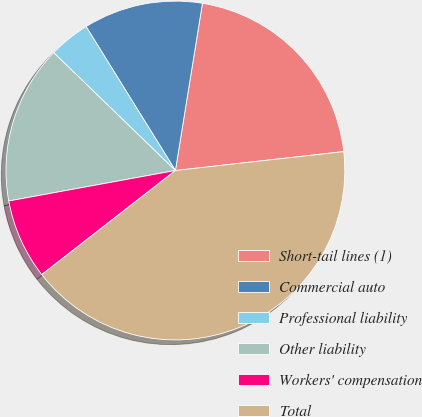Convert chart. <chart><loc_0><loc_0><loc_500><loc_500><pie_chart><fcel>Short-tail lines (1)<fcel>Commercial auto<fcel>Professional liability<fcel>Other liability<fcel>Workers' compensation<fcel>Total<nl><fcel>20.67%<fcel>11.39%<fcel>3.92%<fcel>15.12%<fcel>7.65%<fcel>41.25%<nl></chart> 